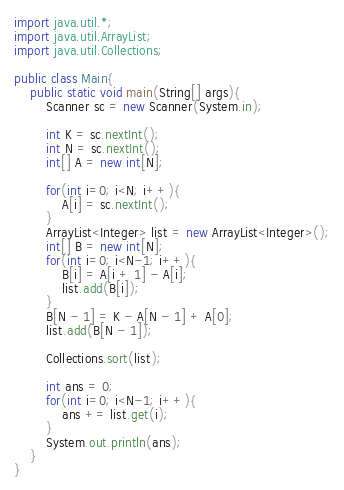Convert code to text. <code><loc_0><loc_0><loc_500><loc_500><_Java_>import java.util.*;
import java.util.ArrayList;
import java.util.Collections;
 
public class Main{
    public static void main(String[] args){
        Scanner sc = new Scanner(System.in);
 
        int K = sc.nextInt();
        int N = sc.nextInt();
        int[] A = new int[N];

        for(int i=0; i<N; i++){
            A[i] = sc.nextInt();
        }
        ArrayList<Integer> list = new ArrayList<Integer>();
        int[] B = new int[N];
        for(int i=0; i<N-1; i++){
            B[i] = A[i + 1] - A[i];
            list.add(B[i]);
        }
        B[N - 1] = K - A[N - 1] + A[0];
        list.add(B[N - 1]);

        Collections.sort(list);

        int ans = 0;
        for(int i=0; i<N-1; i++){
            ans += list.get(i);
        }
        System.out.println(ans);
    }
}</code> 